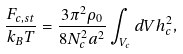Convert formula to latex. <formula><loc_0><loc_0><loc_500><loc_500>\frac { F _ { c , s t } } { k _ { B } T } = \frac { 3 \pi ^ { 2 } \rho _ { 0 } } { 8 N _ { c } ^ { 2 } a ^ { 2 } } \int _ { V _ { c } } d V h _ { c } ^ { 2 } ,</formula> 